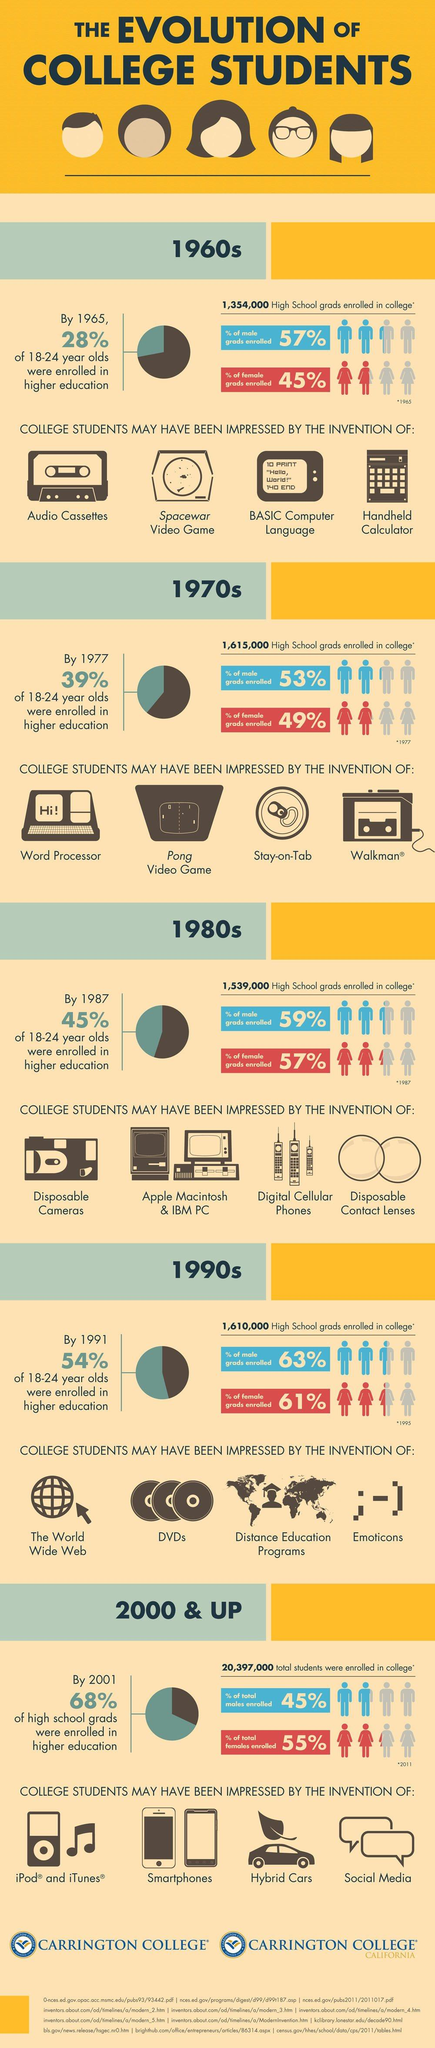Give some essential details in this illustration. During the 1960s, BASIC was the predominantly used programming language. The Walkman was invented in the 1970s. In the 1990s, the world was introduced to several innovative inventions that greatly impressed college students, including the invention of the World Wide Web, the development of DVDs, and the introduction of distance education programs. These inventions revolutionized the way people communicate, access and share information, and receive education. They opened up new possibilities for learning and entertainment and have continued to shape our lives and society in the decades since. The 1980s saw a decrease in the number of high school graduates enrolled in colleges. The enrollment of male graduates was higher than that of female graduates in the 1980s by a percentage of 2%. 